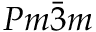Convert formula to latex. <formula><loc_0><loc_0><loc_500><loc_500>P m \bar { 3 } m</formula> 